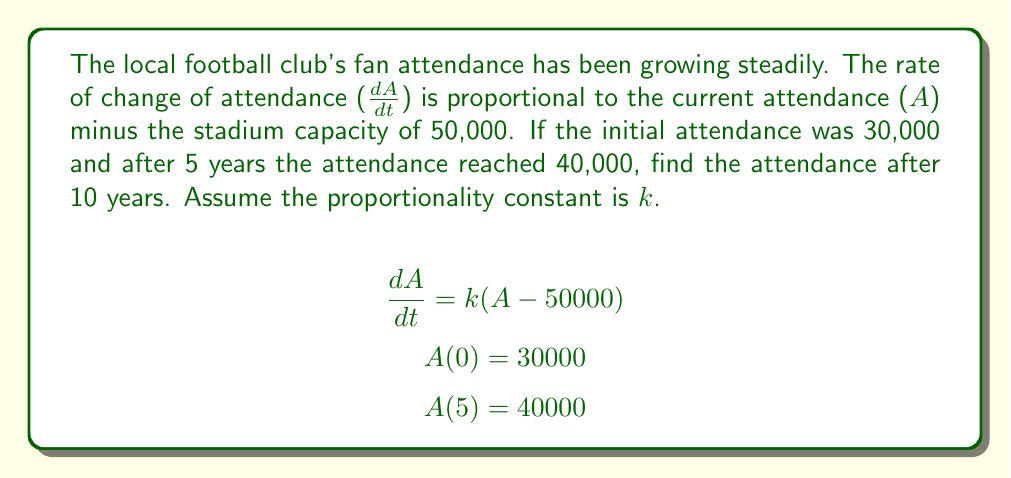Give your solution to this math problem. Let's solve this step-by-step:

1) We have a first-order linear differential equation:
   $$\frac{dA}{dt} = k(A - 50000)$$

2) This is separable. Let's rearrange and integrate:
   $$\int \frac{dA}{A - 50000} = \int k dt$$

3) Solving the left side:
   $$\ln|A - 50000| = kt + C$$

4) Exponentiating both sides:
   $$A - 50000 = Ce^{kt}$$
   $$A = 50000 + Ce^{kt}$$

5) Using the initial condition A(0) = 30000:
   $$30000 = 50000 + Ce^{0}$$
   $$C = -20000$$

6) So our solution is:
   $$A = 50000 - 20000e^{kt}$$

7) Now use the condition A(5) = 40000:
   $$40000 = 50000 - 20000e^{5k}$$
   $$-10000 = -20000e^{5k}$$
   $$\frac{1}{2} = e^{5k}$$
   $$\ln(\frac{1}{2}) = 5k$$
   $$k = \frac{\ln(\frac{1}{2})}{5} = -0.1386$$

8) Now we have our complete solution:
   $$A = 50000 - 20000e^{-0.1386t}$$

9) To find attendance after 10 years, plug in t = 10:
   $$A(10) = 50000 - 20000e^{-0.1386(10)}$$
   $$A(10) = 50000 - 20000(0.2506)$$
   $$A(10) = 44988$$
Answer: The attendance after 10 years will be approximately 44,988 fans. 